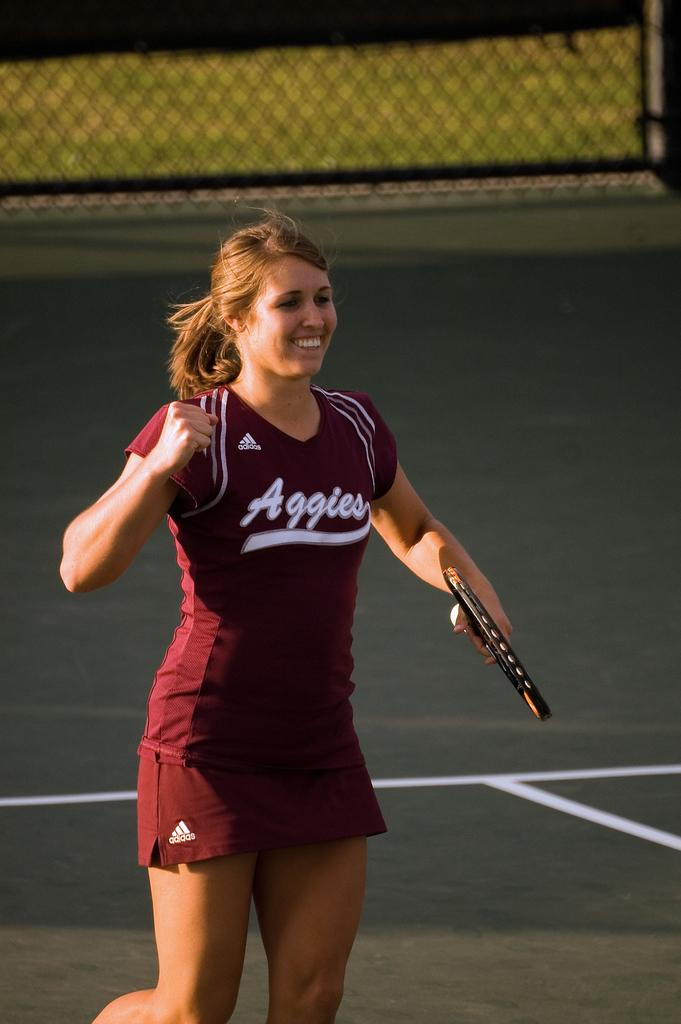Who is the main subject in the image? There is a woman in the image. What is the woman doing in the image? The woman is standing and smiling. What object is the woman holding in the image? The woman is holding a tennis racket. What can be seen in the background of the image? There is a fence in the background of the image. What request does the woman make in the image? There is no indication in the image that the woman is making a request. 